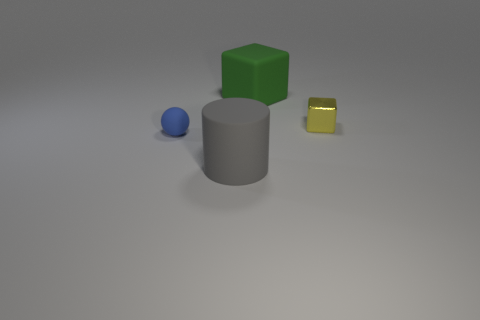Add 1 yellow matte spheres. How many objects exist? 5 Subtract all cylinders. How many objects are left? 3 Add 4 rubber objects. How many rubber objects are left? 7 Add 3 spheres. How many spheres exist? 4 Subtract 0 brown cylinders. How many objects are left? 4 Subtract all small purple rubber things. Subtract all yellow objects. How many objects are left? 3 